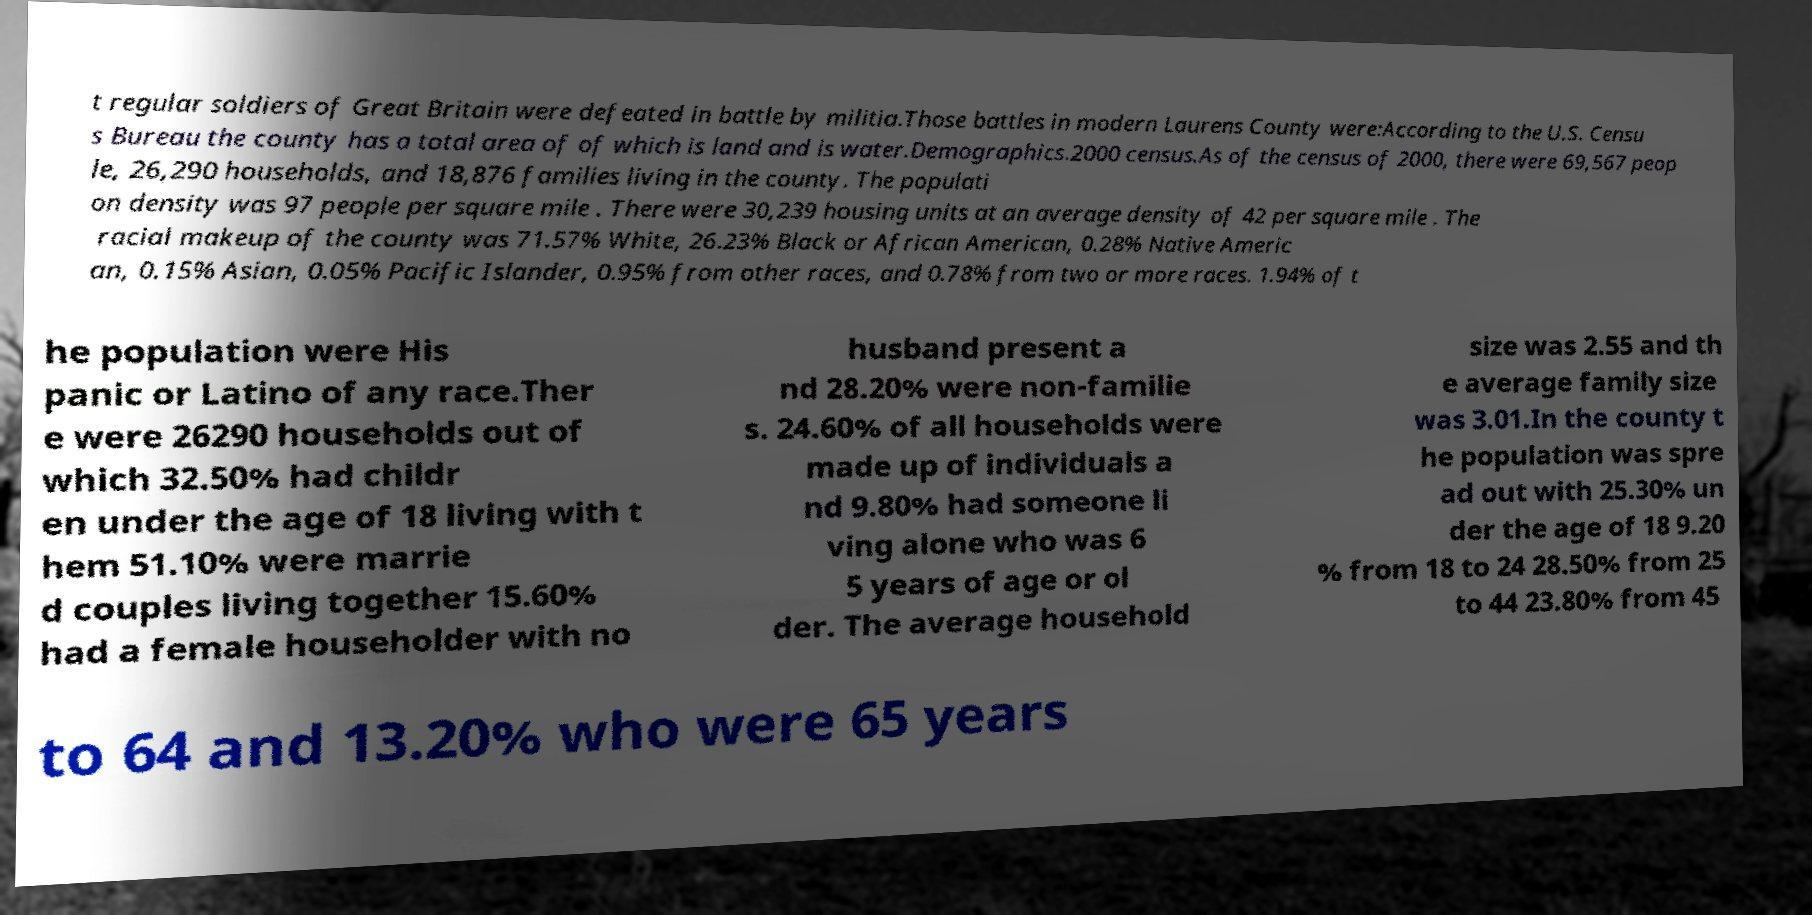Please read and relay the text visible in this image. What does it say? t regular soldiers of Great Britain were defeated in battle by militia.Those battles in modern Laurens County were:According to the U.S. Censu s Bureau the county has a total area of of which is land and is water.Demographics.2000 census.As of the census of 2000, there were 69,567 peop le, 26,290 households, and 18,876 families living in the county. The populati on density was 97 people per square mile . There were 30,239 housing units at an average density of 42 per square mile . The racial makeup of the county was 71.57% White, 26.23% Black or African American, 0.28% Native Americ an, 0.15% Asian, 0.05% Pacific Islander, 0.95% from other races, and 0.78% from two or more races. 1.94% of t he population were His panic or Latino of any race.Ther e were 26290 households out of which 32.50% had childr en under the age of 18 living with t hem 51.10% were marrie d couples living together 15.60% had a female householder with no husband present a nd 28.20% were non-familie s. 24.60% of all households were made up of individuals a nd 9.80% had someone li ving alone who was 6 5 years of age or ol der. The average household size was 2.55 and th e average family size was 3.01.In the county t he population was spre ad out with 25.30% un der the age of 18 9.20 % from 18 to 24 28.50% from 25 to 44 23.80% from 45 to 64 and 13.20% who were 65 years 